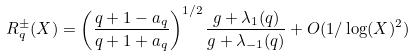Convert formula to latex. <formula><loc_0><loc_0><loc_500><loc_500>R ^ { \pm } _ { q } ( X ) = \left ( \frac { q + 1 - a _ { q } } { q + 1 + a _ { q } } \right ) ^ { 1 / 2 } \frac { g + \lambda _ { 1 } ( q ) } { g + \lambda _ { - 1 } ( q ) } + O ( 1 / \log ( X ) ^ { 2 } )</formula> 